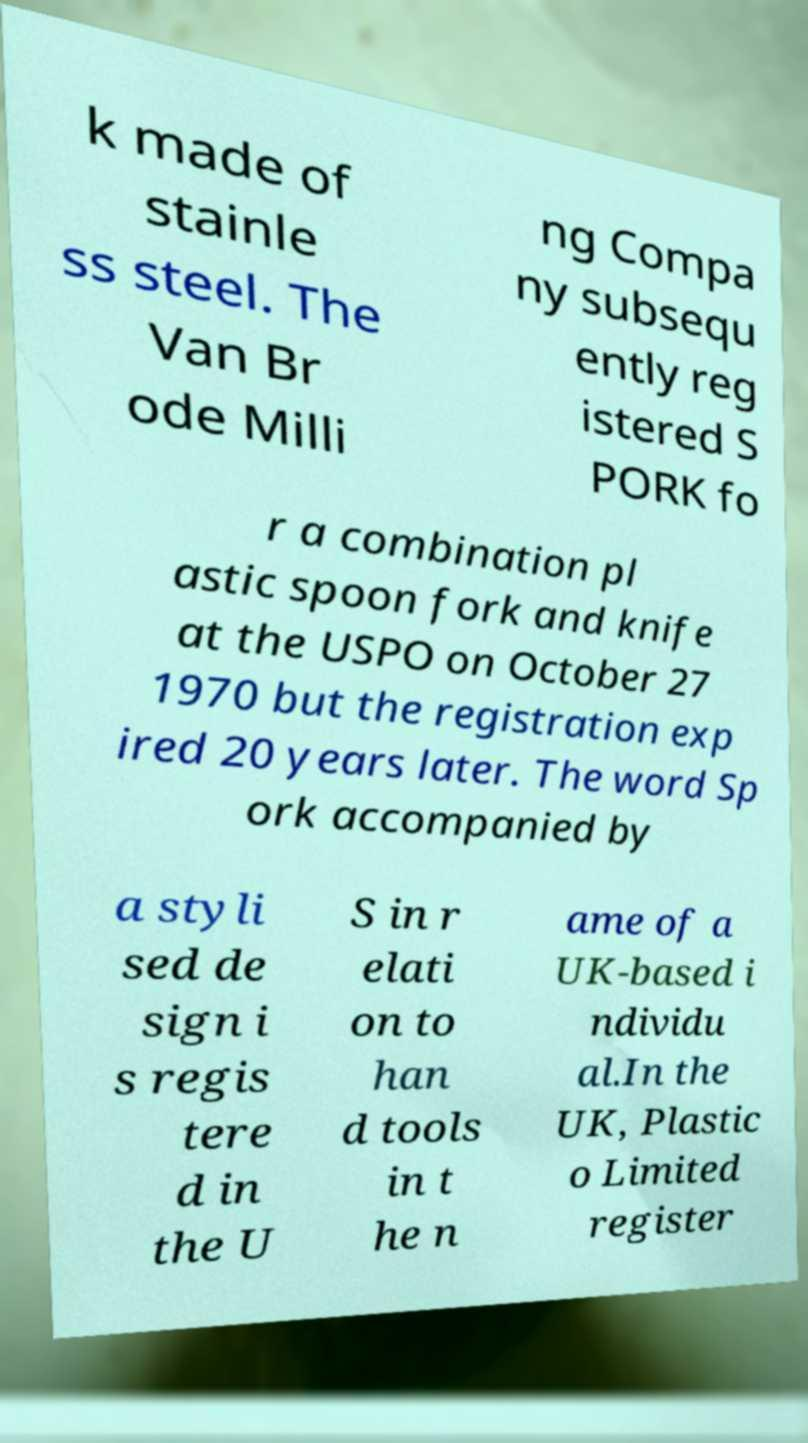I need the written content from this picture converted into text. Can you do that? k made of stainle ss steel. The Van Br ode Milli ng Compa ny subsequ ently reg istered S PORK fo r a combination pl astic spoon fork and knife at the USPO on October 27 1970 but the registration exp ired 20 years later. The word Sp ork accompanied by a styli sed de sign i s regis tere d in the U S in r elati on to han d tools in t he n ame of a UK-based i ndividu al.In the UK, Plastic o Limited register 